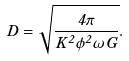<formula> <loc_0><loc_0><loc_500><loc_500>D = \sqrt { \frac { 4 \pi } { K ^ { 2 } \phi ^ { 2 } \omega G } } .</formula> 